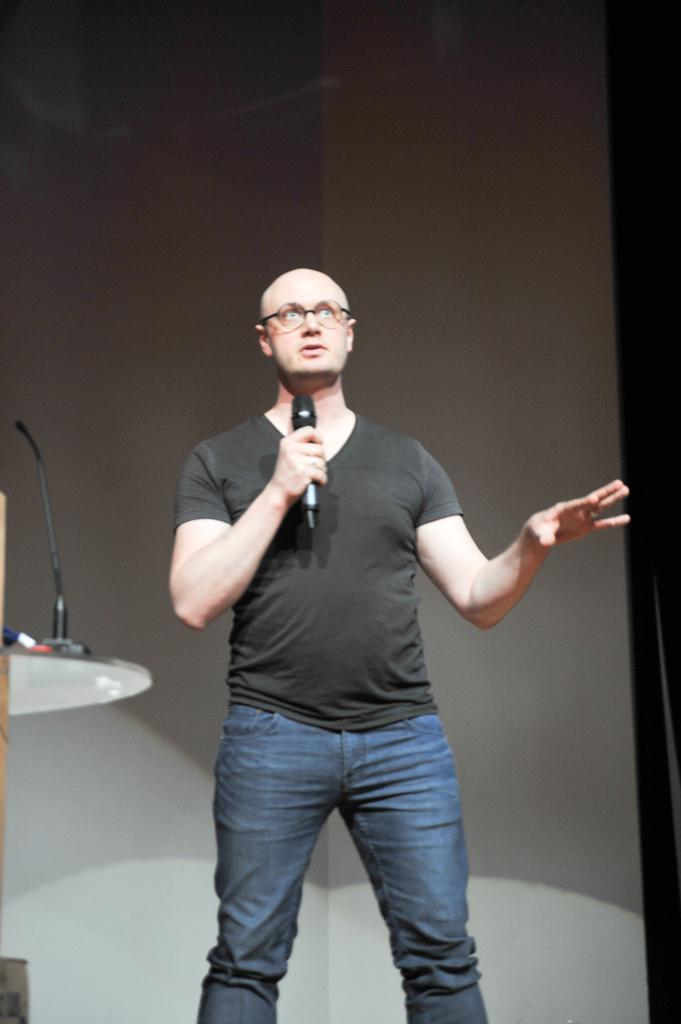What is the main subject of the image? The main subject of the image is a man. What is the man doing in the image? The man is standing and talking in the image. What is the man holding in his hand? The man is holding a mic in his hand. What else can be seen in the image related to the man's activity? There is a mic stand on a table in the image. What is visible in the background of the image? There is a wall in the background of the image. What type of flowers can be seen on the man's shirt in the image? There are no flowers visible on the man's shirt in the image. What is the kitten's opinion about the man's speech in the image? There is no kitten present in the image, so it cannot have an opinion about the man's speech. 